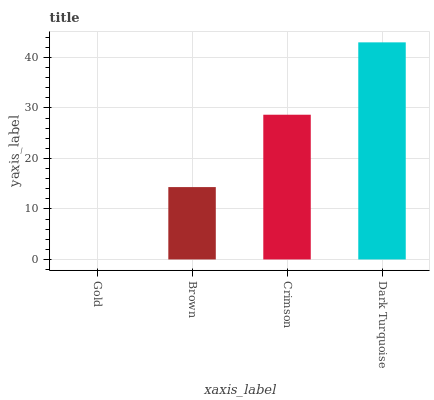Is Gold the minimum?
Answer yes or no. Yes. Is Dark Turquoise the maximum?
Answer yes or no. Yes. Is Brown the minimum?
Answer yes or no. No. Is Brown the maximum?
Answer yes or no. No. Is Brown greater than Gold?
Answer yes or no. Yes. Is Gold less than Brown?
Answer yes or no. Yes. Is Gold greater than Brown?
Answer yes or no. No. Is Brown less than Gold?
Answer yes or no. No. Is Crimson the high median?
Answer yes or no. Yes. Is Brown the low median?
Answer yes or no. Yes. Is Gold the high median?
Answer yes or no. No. Is Crimson the low median?
Answer yes or no. No. 